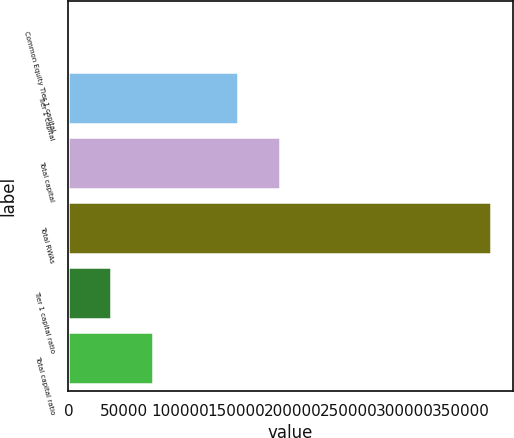Convert chart to OTSL. <chart><loc_0><loc_0><loc_500><loc_500><bar_chart><fcel>Common Equity Tier 1 capital<fcel>Tier 1 capital<fcel>Total capital<fcel>Total RWAs<fcel>Tier 1 capital ratio<fcel>Total capital ratio<nl><fcel>16.1<fcel>150906<fcel>188629<fcel>377241<fcel>37738.6<fcel>75461.1<nl></chart> 